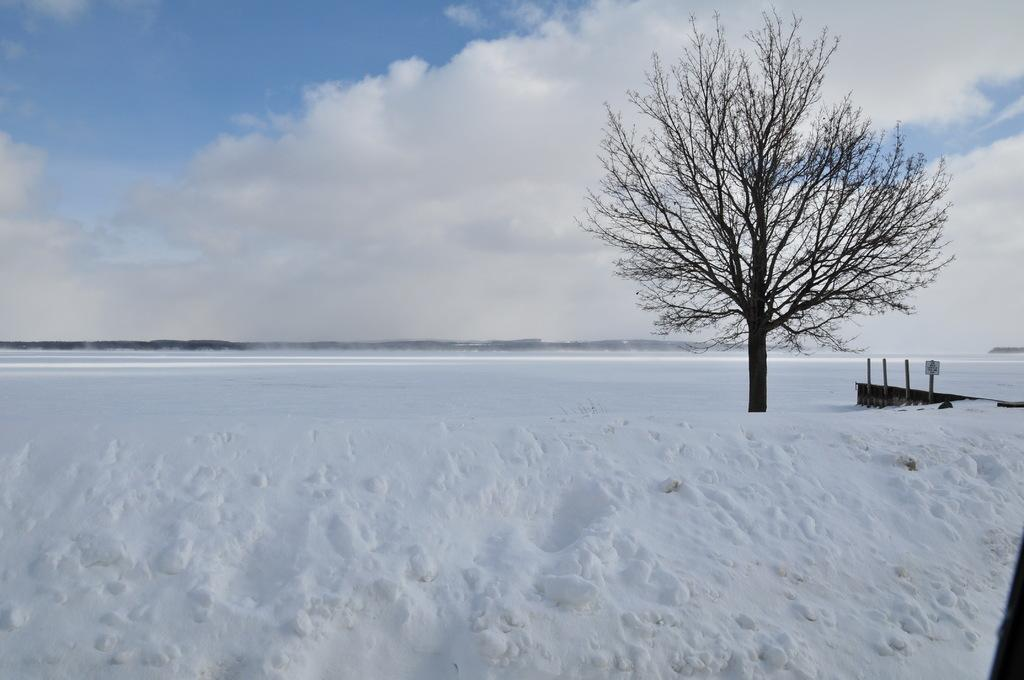What is the color and condition of the sky in the image? The sky in the image is blue and cloudy. What type of vegetation can be seen in the image? There is a tree in the image. What type of weather is suggested by the presence of snow in the image? Snow is present around the area in the image, suggesting cold weather. Can you see an apple hanging from the tree in the image? There is no apple visible on the tree in the image. What type of paper is being used as an example in the image? There is no paper or example present in the image. 